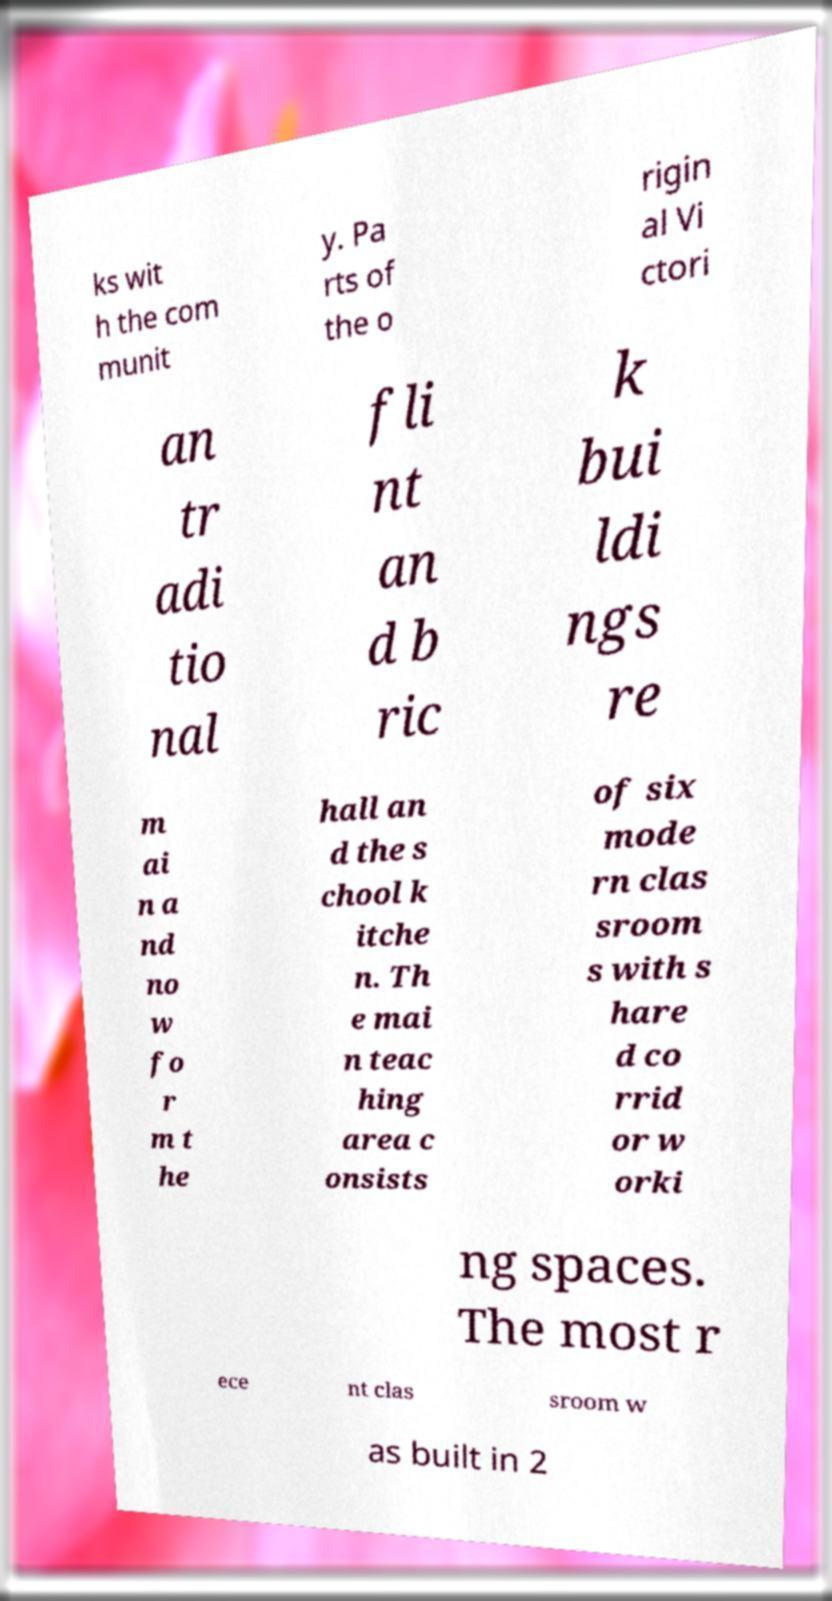There's text embedded in this image that I need extracted. Can you transcribe it verbatim? ks wit h the com munit y. Pa rts of the o rigin al Vi ctori an tr adi tio nal fli nt an d b ric k bui ldi ngs re m ai n a nd no w fo r m t he hall an d the s chool k itche n. Th e mai n teac hing area c onsists of six mode rn clas sroom s with s hare d co rrid or w orki ng spaces. The most r ece nt clas sroom w as built in 2 